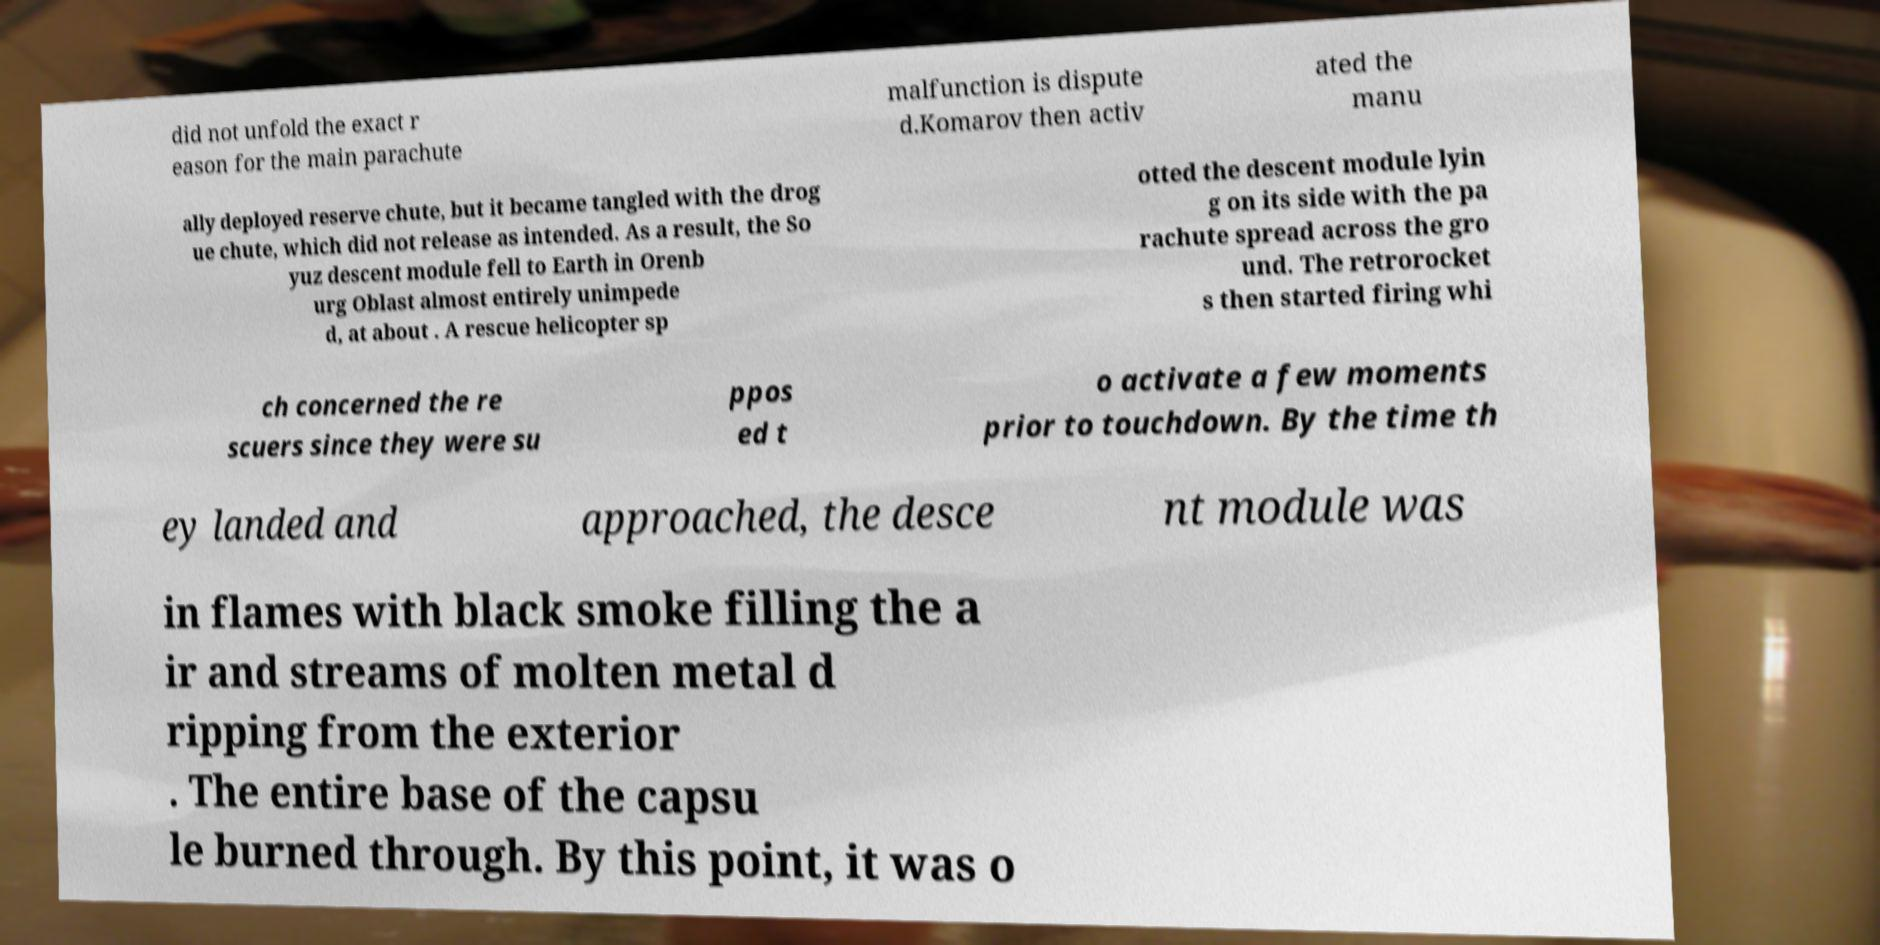Please read and relay the text visible in this image. What does it say? did not unfold the exact r eason for the main parachute malfunction is dispute d.Komarov then activ ated the manu ally deployed reserve chute, but it became tangled with the drog ue chute, which did not release as intended. As a result, the So yuz descent module fell to Earth in Orenb urg Oblast almost entirely unimpede d, at about . A rescue helicopter sp otted the descent module lyin g on its side with the pa rachute spread across the gro und. The retrorocket s then started firing whi ch concerned the re scuers since they were su ppos ed t o activate a few moments prior to touchdown. By the time th ey landed and approached, the desce nt module was in flames with black smoke filling the a ir and streams of molten metal d ripping from the exterior . The entire base of the capsu le burned through. By this point, it was o 